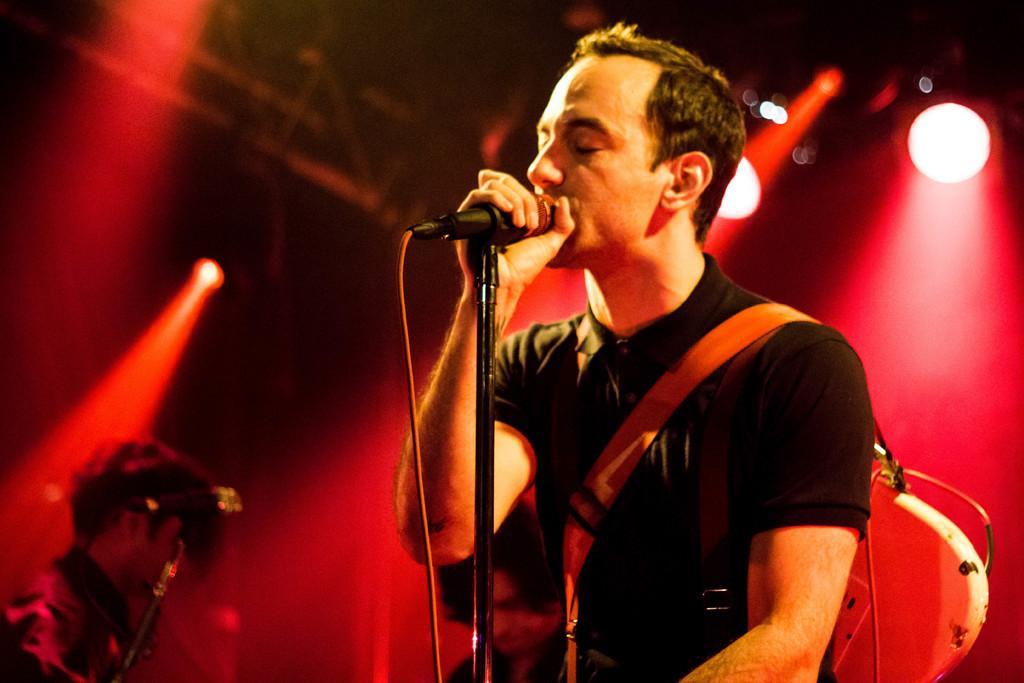Please provide a concise description of this image. In this image we can see some men standing. One person is wearing a guitar and holding a microphone with cable with his hands. On the left side of the image we can see a microphone on a stand. In the background, we can see metal frame and some lights. 